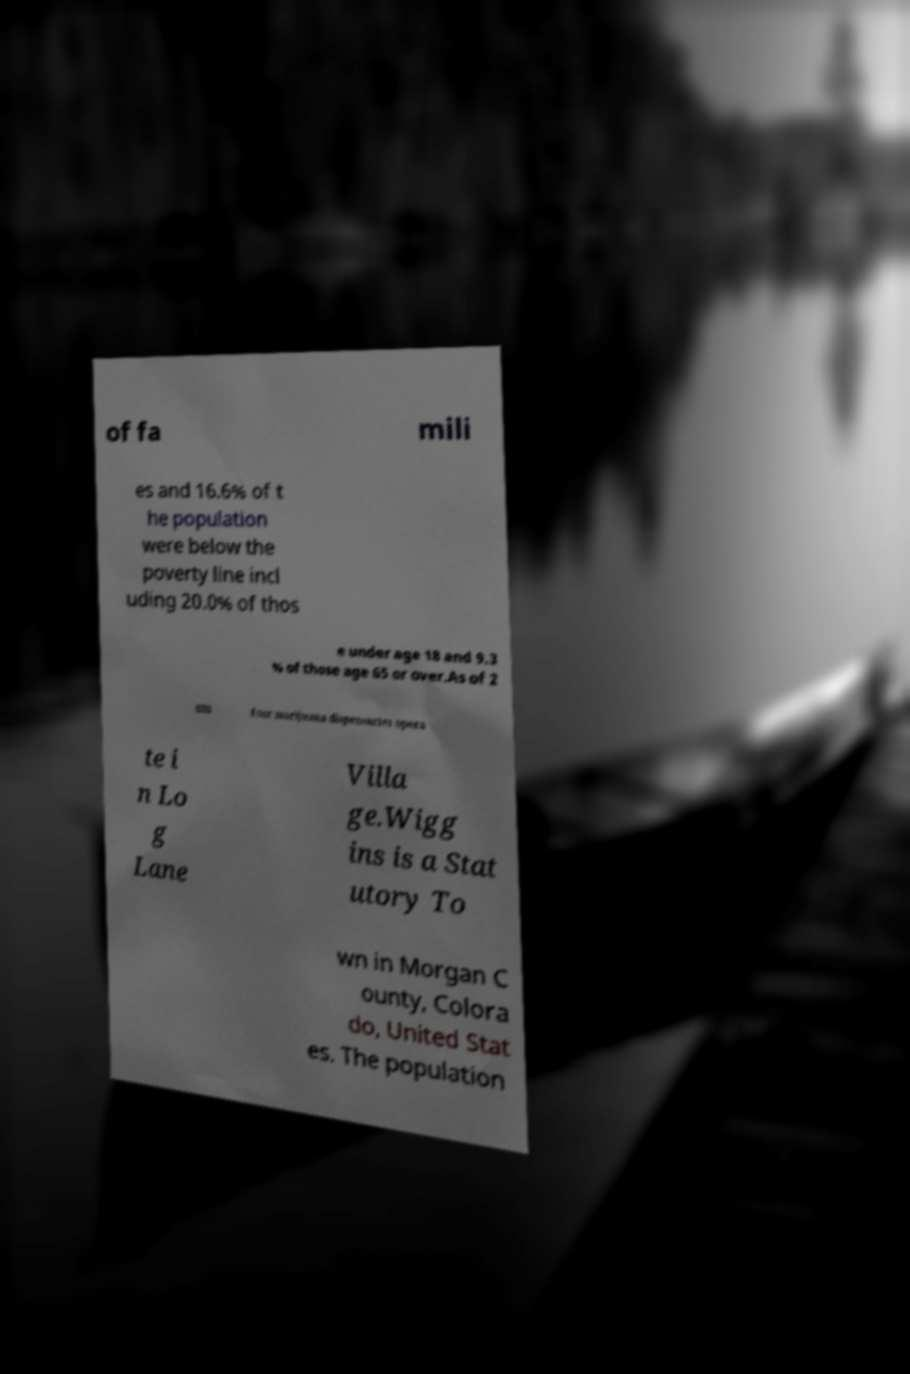Could you assist in decoding the text presented in this image and type it out clearly? of fa mili es and 16.6% of t he population were below the poverty line incl uding 20.0% of thos e under age 18 and 9.3 % of those age 65 or over.As of 2 020 four marijuana dispensaries opera te i n Lo g Lane Villa ge.Wigg ins is a Stat utory To wn in Morgan C ounty, Colora do, United Stat es. The population 